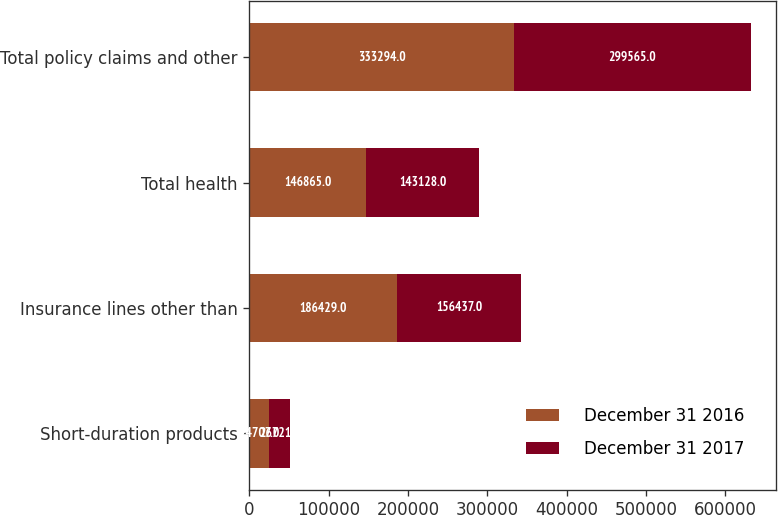Convert chart to OTSL. <chart><loc_0><loc_0><loc_500><loc_500><stacked_bar_chart><ecel><fcel>Short-duration products<fcel>Insurance lines other than<fcel>Total health<fcel>Total policy claims and other<nl><fcel>December 31 2016<fcel>24707<fcel>186429<fcel>146865<fcel>333294<nl><fcel>December 31 2017<fcel>26721<fcel>156437<fcel>143128<fcel>299565<nl></chart> 